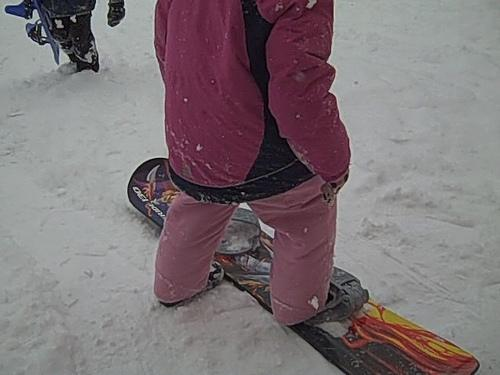How would it be if she tried to snowboard assis? Please explain your reasoning. too dangerous. It would be very dangerous. 